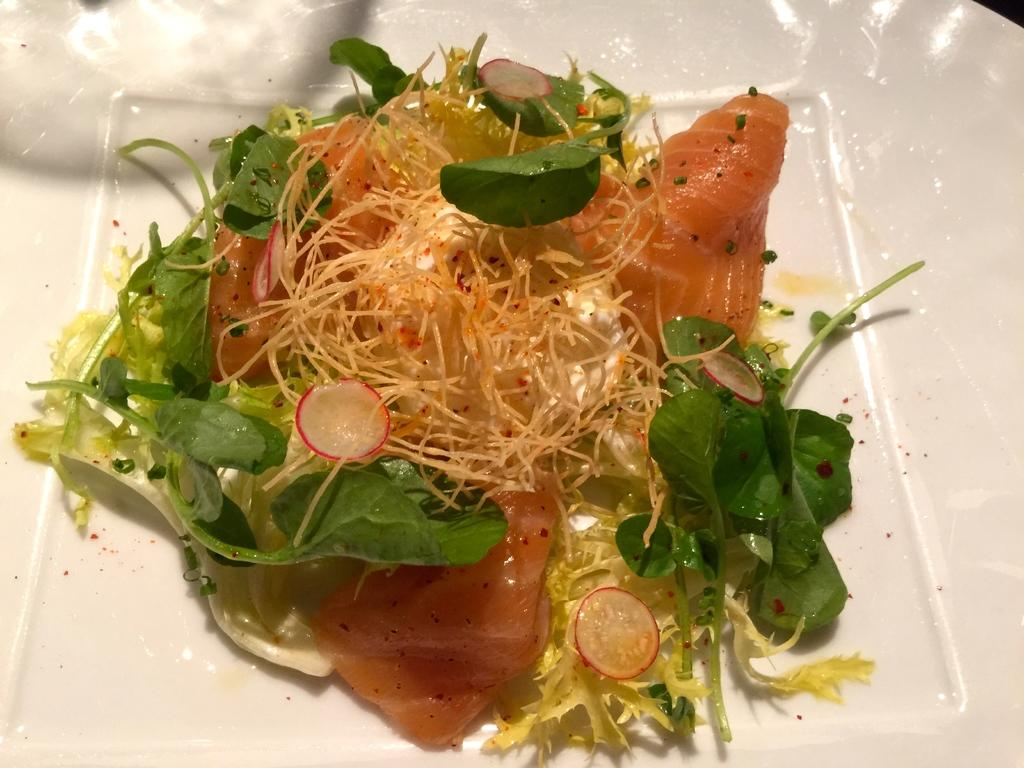What is on the plate that is visible in the image? There is food on the plate in the image. What color is the plate in the image? The plate is white. What type of vegetation is present in the image? There are green color leaves in the image. What year is depicted in the image? There is no indication of a specific year in the image. Is there a knife visible on the plate in the image? There is no knife visible on the plate in the image. 